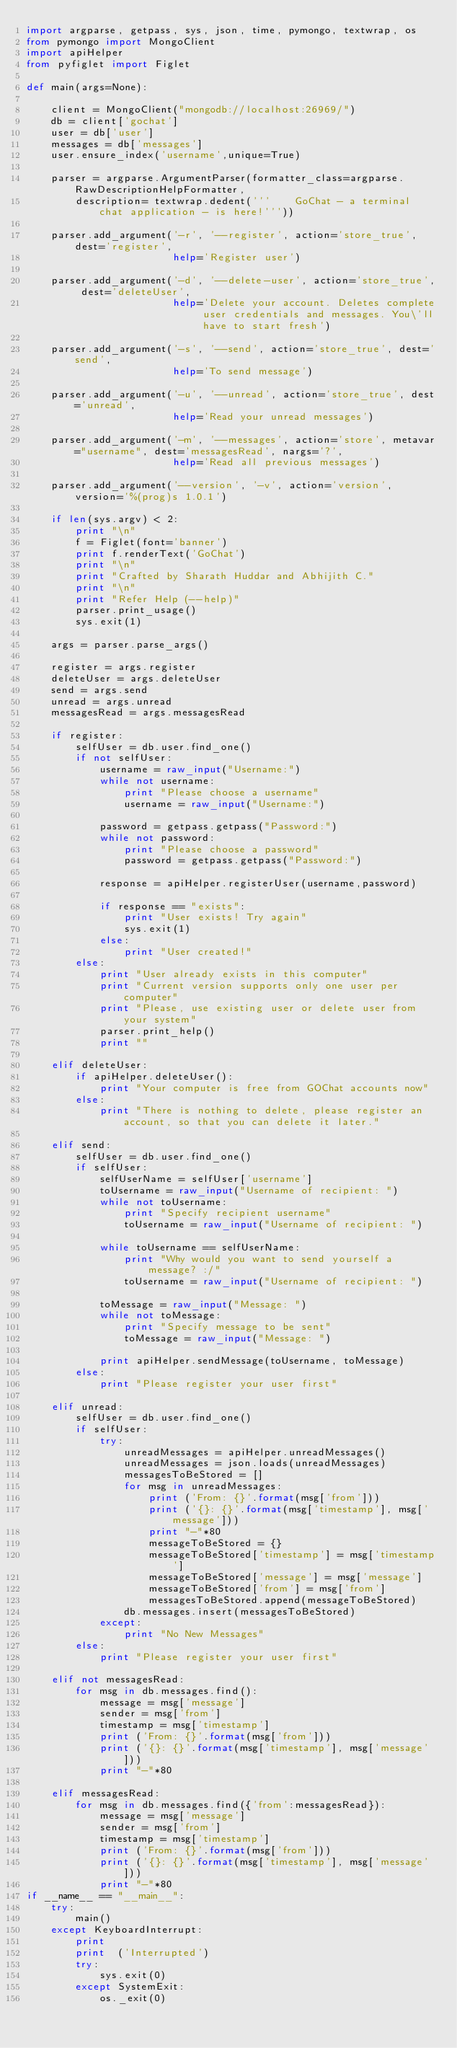<code> <loc_0><loc_0><loc_500><loc_500><_Python_>import argparse, getpass, sys, json, time, pymongo, textwrap, os
from pymongo import MongoClient
import apiHelper
from pyfiglet import Figlet

def main(args=None):

    client = MongoClient("mongodb://localhost:26969/")
    db = client['gochat']
    user = db['user']
    messages = db['messages']
    user.ensure_index('username',unique=True)

    parser = argparse.ArgumentParser(formatter_class=argparse.RawDescriptionHelpFormatter,
    	description= textwrap.dedent('''	GoChat - a terminal chat application - is here!'''))

    parser.add_argument('-r', '--register', action='store_true', dest='register',
    					help='Register user')

    parser.add_argument('-d', '--delete-user', action='store_true', dest='deleteUser',
    					help='Delete your account. Deletes complete user credentials and messages. You\'ll have to start fresh')

    parser.add_argument('-s', '--send', action='store_true', dest='send',
    					help='To send message')

    parser.add_argument('-u', '--unread', action='store_true', dest='unread',
    					help='Read your unread messages')

    parser.add_argument('-m', '--messages', action='store', metavar="username", dest='messagesRead', nargs='?',
    					help='Read all previous messages')

    parser.add_argument('--version', '-v', action='version', version='%(prog)s 1.0.1')

    if len(sys.argv) < 2:
    	print "\n"
        f = Figlet(font='banner')
        print f.renderText('GoChat')
    	print "\n"
    	print "Crafted by Sharath Huddar and Abhijith C."
    	print "\n"
    	print "Refer Help (--help)"
    	parser.print_usage()
    	sys.exit(1)

    args = parser.parse_args()

    register = args.register
    deleteUser = args.deleteUser
    send = args.send
    unread = args.unread
    messagesRead = args.messagesRead

    if register:
    	selfUser = db.user.find_one()
    	if not selfUser:
    		username = raw_input("Username:")
    		while not username:
    			print "Please choose a username"
    			username = raw_input("Username:")

    		password = getpass.getpass("Password:")
    		while not password:
    			print "Please choose a password"
    			password = getpass.getpass("Password:")

    		response = apiHelper.registerUser(username,password)

    		if response == "exists":
    			print "User exists! Try again"
    			sys.exit(1)
    		else:
    			print "User created!"
    	else:
    		print "User already exists in this computer"
    		print "Current version supports only one user per computer"
    		print "Please, use existing user or delete user from your system"
    		parser.print_help()
    		print ""

    elif deleteUser:
    	if apiHelper.deleteUser():
    		print "Your computer is free from GOChat accounts now"
    	else:
    		print "There is nothing to delete, please register an account, so that you can delete it later."

    elif send:
    	selfUser = db.user.find_one()
    	if selfUser:
    		selfUserName = selfUser['username']
    		toUsername = raw_input("Username of recipient: ")
    		while not toUsername:
    			print "Specify recipient username"
    			toUsername = raw_input("Username of recipient: ")

    		while toUsername == selfUserName:
    			print "Why would you want to send yourself a message? :/"
    			toUsername = raw_input("Username of recipient: ")

    		toMessage = raw_input("Message: ")
    		while not toMessage:
    			print "Specify message to be sent"
    			toMessage = raw_input("Message: ")

    		print apiHelper.sendMessage(toUsername, toMessage)
    	else:
    		print "Please register your user first"

    elif unread:
    	selfUser = db.user.find_one()
    	if selfUser:
    		try:
    			unreadMessages = apiHelper.unreadMessages()
    			unreadMessages = json.loads(unreadMessages)
    			messagesToBeStored = []
    			for msg in unreadMessages:
    				print ('From: {}'.format(msg['from']))
    				print ('{}: {}'.format(msg['timestamp'], msg['message']))
    				print "-"*80
    				messageToBeStored = {}
    				messageToBeStored['timestamp'] = msg['timestamp']
    				messageToBeStored['message'] = msg['message']
    				messageToBeStored['from'] = msg['from']
    				messagesToBeStored.append(messageToBeStored)
    			db.messages.insert(messagesToBeStored)
    		except:
    			print "No New Messages"
    	else:
    		print "Please register your user first"

    elif not messagesRead:
    	for msg in db.messages.find():
    		message = msg['message']
    		sender = msg['from']
    		timestamp = msg['timestamp']
    		print ('From: {}'.format(msg['from']))
    		print ('{}: {}'.format(msg['timestamp'], msg['message']))
    		print "-"*80

    elif messagesRead:
    	for msg in db.messages.find({'from':messagesRead}):
    		message = msg['message']
    		sender = msg['from']
    		timestamp = msg['timestamp']
    		print ('From: {}'.format(msg['from']))
    		print ('{}: {}'.format(msg['timestamp'], msg['message']))
    		print "-"*80
if __name__ == "__main__":
    try:
        main()
    except KeyboardInterrupt:
        print
        print  ('Interrupted')
        try:
            sys.exit(0)
        except SystemExit:
            os._exit(0)
</code> 